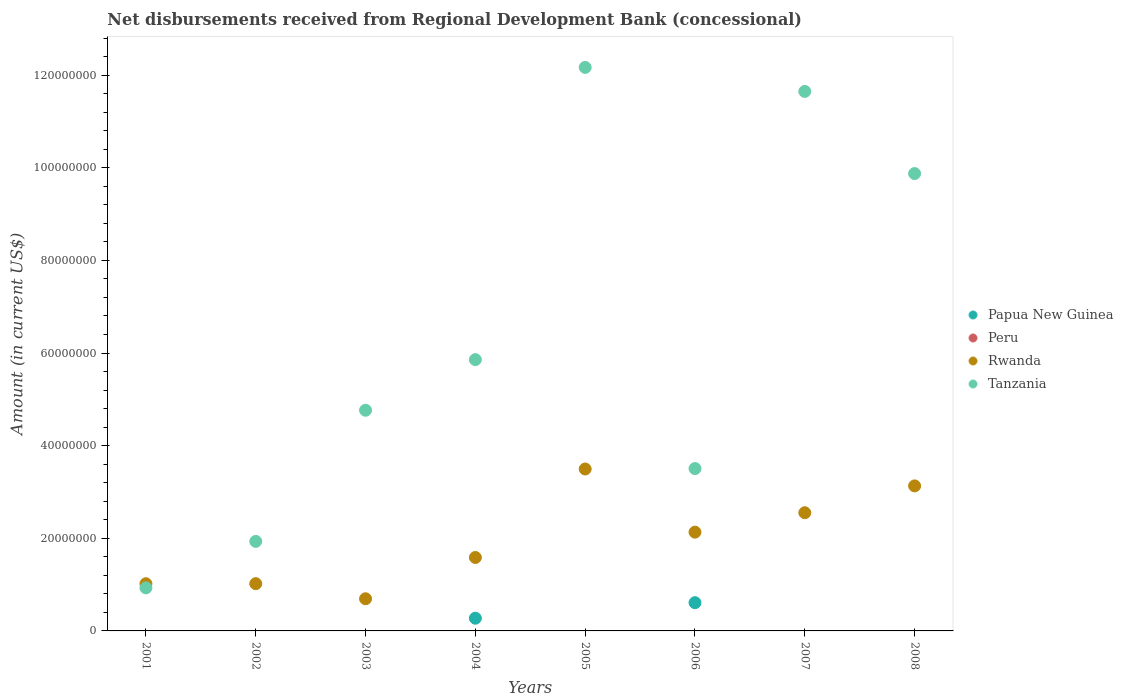How many different coloured dotlines are there?
Give a very brief answer. 3. Is the number of dotlines equal to the number of legend labels?
Keep it short and to the point. No. What is the amount of disbursements received from Regional Development Bank in Rwanda in 2008?
Ensure brevity in your answer.  3.13e+07. Across all years, what is the maximum amount of disbursements received from Regional Development Bank in Rwanda?
Offer a terse response. 3.50e+07. Across all years, what is the minimum amount of disbursements received from Regional Development Bank in Tanzania?
Give a very brief answer. 9.30e+06. What is the total amount of disbursements received from Regional Development Bank in Peru in the graph?
Your answer should be very brief. 0. What is the difference between the amount of disbursements received from Regional Development Bank in Rwanda in 2004 and that in 2007?
Your answer should be compact. -9.66e+06. What is the difference between the amount of disbursements received from Regional Development Bank in Papua New Guinea in 2006 and the amount of disbursements received from Regional Development Bank in Rwanda in 2008?
Provide a succinct answer. -2.52e+07. What is the average amount of disbursements received from Regional Development Bank in Rwanda per year?
Provide a short and direct response. 1.95e+07. In the year 2007, what is the difference between the amount of disbursements received from Regional Development Bank in Tanzania and amount of disbursements received from Regional Development Bank in Rwanda?
Provide a succinct answer. 9.10e+07. What is the ratio of the amount of disbursements received from Regional Development Bank in Rwanda in 2002 to that in 2004?
Offer a terse response. 0.64. Is the amount of disbursements received from Regional Development Bank in Tanzania in 2006 less than that in 2008?
Make the answer very short. Yes. What is the difference between the highest and the second highest amount of disbursements received from Regional Development Bank in Rwanda?
Your response must be concise. 3.65e+06. What is the difference between the highest and the lowest amount of disbursements received from Regional Development Bank in Papua New Guinea?
Offer a very short reply. 6.10e+06. Is the sum of the amount of disbursements received from Regional Development Bank in Rwanda in 2001 and 2002 greater than the maximum amount of disbursements received from Regional Development Bank in Peru across all years?
Make the answer very short. Yes. Is it the case that in every year, the sum of the amount of disbursements received from Regional Development Bank in Rwanda and amount of disbursements received from Regional Development Bank in Papua New Guinea  is greater than the amount of disbursements received from Regional Development Bank in Tanzania?
Give a very brief answer. No. Is the amount of disbursements received from Regional Development Bank in Papua New Guinea strictly less than the amount of disbursements received from Regional Development Bank in Rwanda over the years?
Provide a succinct answer. Yes. How many dotlines are there?
Keep it short and to the point. 3. Are the values on the major ticks of Y-axis written in scientific E-notation?
Your answer should be very brief. No. Does the graph contain any zero values?
Ensure brevity in your answer.  Yes. Does the graph contain grids?
Provide a short and direct response. No. How are the legend labels stacked?
Make the answer very short. Vertical. What is the title of the graph?
Your response must be concise. Net disbursements received from Regional Development Bank (concessional). Does "Sweden" appear as one of the legend labels in the graph?
Provide a succinct answer. No. What is the label or title of the Y-axis?
Offer a very short reply. Amount (in current US$). What is the Amount (in current US$) in Papua New Guinea in 2001?
Provide a short and direct response. 0. What is the Amount (in current US$) in Rwanda in 2001?
Give a very brief answer. 1.02e+07. What is the Amount (in current US$) of Tanzania in 2001?
Provide a succinct answer. 9.30e+06. What is the Amount (in current US$) in Papua New Guinea in 2002?
Give a very brief answer. 0. What is the Amount (in current US$) in Rwanda in 2002?
Offer a very short reply. 1.02e+07. What is the Amount (in current US$) in Tanzania in 2002?
Your answer should be very brief. 1.93e+07. What is the Amount (in current US$) in Peru in 2003?
Keep it short and to the point. 0. What is the Amount (in current US$) of Rwanda in 2003?
Provide a succinct answer. 6.94e+06. What is the Amount (in current US$) in Tanzania in 2003?
Make the answer very short. 4.76e+07. What is the Amount (in current US$) in Papua New Guinea in 2004?
Your answer should be compact. 2.74e+06. What is the Amount (in current US$) of Rwanda in 2004?
Provide a short and direct response. 1.59e+07. What is the Amount (in current US$) of Tanzania in 2004?
Your answer should be very brief. 5.86e+07. What is the Amount (in current US$) of Papua New Guinea in 2005?
Make the answer very short. 0. What is the Amount (in current US$) in Rwanda in 2005?
Keep it short and to the point. 3.50e+07. What is the Amount (in current US$) of Tanzania in 2005?
Ensure brevity in your answer.  1.22e+08. What is the Amount (in current US$) in Papua New Guinea in 2006?
Keep it short and to the point. 6.10e+06. What is the Amount (in current US$) of Peru in 2006?
Offer a terse response. 0. What is the Amount (in current US$) in Rwanda in 2006?
Give a very brief answer. 2.13e+07. What is the Amount (in current US$) of Tanzania in 2006?
Make the answer very short. 3.51e+07. What is the Amount (in current US$) in Papua New Guinea in 2007?
Give a very brief answer. 0. What is the Amount (in current US$) of Peru in 2007?
Your answer should be very brief. 0. What is the Amount (in current US$) of Rwanda in 2007?
Your answer should be very brief. 2.55e+07. What is the Amount (in current US$) in Tanzania in 2007?
Provide a succinct answer. 1.16e+08. What is the Amount (in current US$) in Papua New Guinea in 2008?
Make the answer very short. 0. What is the Amount (in current US$) in Peru in 2008?
Your answer should be very brief. 0. What is the Amount (in current US$) in Rwanda in 2008?
Provide a succinct answer. 3.13e+07. What is the Amount (in current US$) in Tanzania in 2008?
Make the answer very short. 9.87e+07. Across all years, what is the maximum Amount (in current US$) in Papua New Guinea?
Make the answer very short. 6.10e+06. Across all years, what is the maximum Amount (in current US$) in Rwanda?
Keep it short and to the point. 3.50e+07. Across all years, what is the maximum Amount (in current US$) of Tanzania?
Your answer should be compact. 1.22e+08. Across all years, what is the minimum Amount (in current US$) in Rwanda?
Make the answer very short. 6.94e+06. Across all years, what is the minimum Amount (in current US$) in Tanzania?
Ensure brevity in your answer.  9.30e+06. What is the total Amount (in current US$) in Papua New Guinea in the graph?
Ensure brevity in your answer.  8.84e+06. What is the total Amount (in current US$) in Rwanda in the graph?
Provide a succinct answer. 1.56e+08. What is the total Amount (in current US$) in Tanzania in the graph?
Your answer should be very brief. 5.07e+08. What is the difference between the Amount (in current US$) of Rwanda in 2001 and that in 2002?
Offer a terse response. -1.30e+04. What is the difference between the Amount (in current US$) in Tanzania in 2001 and that in 2002?
Offer a terse response. -1.00e+07. What is the difference between the Amount (in current US$) in Rwanda in 2001 and that in 2003?
Ensure brevity in your answer.  3.25e+06. What is the difference between the Amount (in current US$) of Tanzania in 2001 and that in 2003?
Keep it short and to the point. -3.83e+07. What is the difference between the Amount (in current US$) of Rwanda in 2001 and that in 2004?
Keep it short and to the point. -5.66e+06. What is the difference between the Amount (in current US$) of Tanzania in 2001 and that in 2004?
Offer a terse response. -4.93e+07. What is the difference between the Amount (in current US$) in Rwanda in 2001 and that in 2005?
Your response must be concise. -2.48e+07. What is the difference between the Amount (in current US$) in Tanzania in 2001 and that in 2005?
Offer a terse response. -1.12e+08. What is the difference between the Amount (in current US$) of Rwanda in 2001 and that in 2006?
Offer a terse response. -1.11e+07. What is the difference between the Amount (in current US$) in Tanzania in 2001 and that in 2006?
Offer a very short reply. -2.58e+07. What is the difference between the Amount (in current US$) of Rwanda in 2001 and that in 2007?
Your answer should be very brief. -1.53e+07. What is the difference between the Amount (in current US$) of Tanzania in 2001 and that in 2007?
Give a very brief answer. -1.07e+08. What is the difference between the Amount (in current US$) in Rwanda in 2001 and that in 2008?
Make the answer very short. -2.11e+07. What is the difference between the Amount (in current US$) in Tanzania in 2001 and that in 2008?
Your answer should be compact. -8.94e+07. What is the difference between the Amount (in current US$) in Rwanda in 2002 and that in 2003?
Give a very brief answer. 3.26e+06. What is the difference between the Amount (in current US$) in Tanzania in 2002 and that in 2003?
Your answer should be compact. -2.83e+07. What is the difference between the Amount (in current US$) of Rwanda in 2002 and that in 2004?
Your answer should be very brief. -5.65e+06. What is the difference between the Amount (in current US$) of Tanzania in 2002 and that in 2004?
Give a very brief answer. -3.92e+07. What is the difference between the Amount (in current US$) of Rwanda in 2002 and that in 2005?
Keep it short and to the point. -2.48e+07. What is the difference between the Amount (in current US$) of Tanzania in 2002 and that in 2005?
Your response must be concise. -1.02e+08. What is the difference between the Amount (in current US$) of Rwanda in 2002 and that in 2006?
Ensure brevity in your answer.  -1.11e+07. What is the difference between the Amount (in current US$) in Tanzania in 2002 and that in 2006?
Provide a succinct answer. -1.57e+07. What is the difference between the Amount (in current US$) of Rwanda in 2002 and that in 2007?
Your response must be concise. -1.53e+07. What is the difference between the Amount (in current US$) of Tanzania in 2002 and that in 2007?
Provide a short and direct response. -9.71e+07. What is the difference between the Amount (in current US$) of Rwanda in 2002 and that in 2008?
Your response must be concise. -2.11e+07. What is the difference between the Amount (in current US$) of Tanzania in 2002 and that in 2008?
Ensure brevity in your answer.  -7.94e+07. What is the difference between the Amount (in current US$) in Rwanda in 2003 and that in 2004?
Offer a very short reply. -8.91e+06. What is the difference between the Amount (in current US$) in Tanzania in 2003 and that in 2004?
Offer a terse response. -1.09e+07. What is the difference between the Amount (in current US$) in Rwanda in 2003 and that in 2005?
Your response must be concise. -2.80e+07. What is the difference between the Amount (in current US$) of Tanzania in 2003 and that in 2005?
Your answer should be compact. -7.40e+07. What is the difference between the Amount (in current US$) of Rwanda in 2003 and that in 2006?
Give a very brief answer. -1.44e+07. What is the difference between the Amount (in current US$) of Tanzania in 2003 and that in 2006?
Ensure brevity in your answer.  1.26e+07. What is the difference between the Amount (in current US$) of Rwanda in 2003 and that in 2007?
Offer a terse response. -1.86e+07. What is the difference between the Amount (in current US$) in Tanzania in 2003 and that in 2007?
Your answer should be very brief. -6.88e+07. What is the difference between the Amount (in current US$) in Rwanda in 2003 and that in 2008?
Make the answer very short. -2.44e+07. What is the difference between the Amount (in current US$) in Tanzania in 2003 and that in 2008?
Your response must be concise. -5.11e+07. What is the difference between the Amount (in current US$) in Rwanda in 2004 and that in 2005?
Make the answer very short. -1.91e+07. What is the difference between the Amount (in current US$) in Tanzania in 2004 and that in 2005?
Make the answer very short. -6.31e+07. What is the difference between the Amount (in current US$) in Papua New Guinea in 2004 and that in 2006?
Offer a very short reply. -3.35e+06. What is the difference between the Amount (in current US$) in Rwanda in 2004 and that in 2006?
Offer a very short reply. -5.47e+06. What is the difference between the Amount (in current US$) of Tanzania in 2004 and that in 2006?
Ensure brevity in your answer.  2.35e+07. What is the difference between the Amount (in current US$) of Rwanda in 2004 and that in 2007?
Keep it short and to the point. -9.66e+06. What is the difference between the Amount (in current US$) in Tanzania in 2004 and that in 2007?
Your answer should be compact. -5.79e+07. What is the difference between the Amount (in current US$) in Rwanda in 2004 and that in 2008?
Ensure brevity in your answer.  -1.55e+07. What is the difference between the Amount (in current US$) of Tanzania in 2004 and that in 2008?
Provide a short and direct response. -4.02e+07. What is the difference between the Amount (in current US$) of Rwanda in 2005 and that in 2006?
Offer a very short reply. 1.36e+07. What is the difference between the Amount (in current US$) in Tanzania in 2005 and that in 2006?
Make the answer very short. 8.66e+07. What is the difference between the Amount (in current US$) of Rwanda in 2005 and that in 2007?
Offer a terse response. 9.44e+06. What is the difference between the Amount (in current US$) of Tanzania in 2005 and that in 2007?
Provide a succinct answer. 5.19e+06. What is the difference between the Amount (in current US$) of Rwanda in 2005 and that in 2008?
Provide a short and direct response. 3.65e+06. What is the difference between the Amount (in current US$) in Tanzania in 2005 and that in 2008?
Offer a very short reply. 2.29e+07. What is the difference between the Amount (in current US$) in Rwanda in 2006 and that in 2007?
Offer a terse response. -4.20e+06. What is the difference between the Amount (in current US$) of Tanzania in 2006 and that in 2007?
Provide a short and direct response. -8.14e+07. What is the difference between the Amount (in current US$) in Rwanda in 2006 and that in 2008?
Make the answer very short. -9.99e+06. What is the difference between the Amount (in current US$) of Tanzania in 2006 and that in 2008?
Keep it short and to the point. -6.37e+07. What is the difference between the Amount (in current US$) in Rwanda in 2007 and that in 2008?
Provide a short and direct response. -5.79e+06. What is the difference between the Amount (in current US$) in Tanzania in 2007 and that in 2008?
Provide a succinct answer. 1.77e+07. What is the difference between the Amount (in current US$) in Rwanda in 2001 and the Amount (in current US$) in Tanzania in 2002?
Provide a short and direct response. -9.14e+06. What is the difference between the Amount (in current US$) in Rwanda in 2001 and the Amount (in current US$) in Tanzania in 2003?
Offer a terse response. -3.75e+07. What is the difference between the Amount (in current US$) in Rwanda in 2001 and the Amount (in current US$) in Tanzania in 2004?
Your response must be concise. -4.84e+07. What is the difference between the Amount (in current US$) in Rwanda in 2001 and the Amount (in current US$) in Tanzania in 2005?
Ensure brevity in your answer.  -1.11e+08. What is the difference between the Amount (in current US$) in Rwanda in 2001 and the Amount (in current US$) in Tanzania in 2006?
Keep it short and to the point. -2.49e+07. What is the difference between the Amount (in current US$) in Rwanda in 2001 and the Amount (in current US$) in Tanzania in 2007?
Offer a very short reply. -1.06e+08. What is the difference between the Amount (in current US$) of Rwanda in 2001 and the Amount (in current US$) of Tanzania in 2008?
Offer a very short reply. -8.86e+07. What is the difference between the Amount (in current US$) in Rwanda in 2002 and the Amount (in current US$) in Tanzania in 2003?
Offer a very short reply. -3.74e+07. What is the difference between the Amount (in current US$) of Rwanda in 2002 and the Amount (in current US$) of Tanzania in 2004?
Ensure brevity in your answer.  -4.84e+07. What is the difference between the Amount (in current US$) in Rwanda in 2002 and the Amount (in current US$) in Tanzania in 2005?
Your answer should be very brief. -1.11e+08. What is the difference between the Amount (in current US$) in Rwanda in 2002 and the Amount (in current US$) in Tanzania in 2006?
Ensure brevity in your answer.  -2.49e+07. What is the difference between the Amount (in current US$) in Rwanda in 2002 and the Amount (in current US$) in Tanzania in 2007?
Give a very brief answer. -1.06e+08. What is the difference between the Amount (in current US$) in Rwanda in 2002 and the Amount (in current US$) in Tanzania in 2008?
Your answer should be very brief. -8.85e+07. What is the difference between the Amount (in current US$) in Rwanda in 2003 and the Amount (in current US$) in Tanzania in 2004?
Make the answer very short. -5.16e+07. What is the difference between the Amount (in current US$) in Rwanda in 2003 and the Amount (in current US$) in Tanzania in 2005?
Give a very brief answer. -1.15e+08. What is the difference between the Amount (in current US$) of Rwanda in 2003 and the Amount (in current US$) of Tanzania in 2006?
Keep it short and to the point. -2.81e+07. What is the difference between the Amount (in current US$) in Rwanda in 2003 and the Amount (in current US$) in Tanzania in 2007?
Provide a succinct answer. -1.10e+08. What is the difference between the Amount (in current US$) of Rwanda in 2003 and the Amount (in current US$) of Tanzania in 2008?
Offer a terse response. -9.18e+07. What is the difference between the Amount (in current US$) of Papua New Guinea in 2004 and the Amount (in current US$) of Rwanda in 2005?
Offer a terse response. -3.22e+07. What is the difference between the Amount (in current US$) in Papua New Guinea in 2004 and the Amount (in current US$) in Tanzania in 2005?
Your response must be concise. -1.19e+08. What is the difference between the Amount (in current US$) of Rwanda in 2004 and the Amount (in current US$) of Tanzania in 2005?
Your answer should be compact. -1.06e+08. What is the difference between the Amount (in current US$) of Papua New Guinea in 2004 and the Amount (in current US$) of Rwanda in 2006?
Provide a succinct answer. -1.86e+07. What is the difference between the Amount (in current US$) of Papua New Guinea in 2004 and the Amount (in current US$) of Tanzania in 2006?
Provide a short and direct response. -3.23e+07. What is the difference between the Amount (in current US$) of Rwanda in 2004 and the Amount (in current US$) of Tanzania in 2006?
Your answer should be very brief. -1.92e+07. What is the difference between the Amount (in current US$) in Papua New Guinea in 2004 and the Amount (in current US$) in Rwanda in 2007?
Your response must be concise. -2.28e+07. What is the difference between the Amount (in current US$) in Papua New Guinea in 2004 and the Amount (in current US$) in Tanzania in 2007?
Ensure brevity in your answer.  -1.14e+08. What is the difference between the Amount (in current US$) of Rwanda in 2004 and the Amount (in current US$) of Tanzania in 2007?
Your answer should be very brief. -1.01e+08. What is the difference between the Amount (in current US$) in Papua New Guinea in 2004 and the Amount (in current US$) in Rwanda in 2008?
Offer a very short reply. -2.86e+07. What is the difference between the Amount (in current US$) of Papua New Guinea in 2004 and the Amount (in current US$) of Tanzania in 2008?
Your answer should be compact. -9.60e+07. What is the difference between the Amount (in current US$) in Rwanda in 2004 and the Amount (in current US$) in Tanzania in 2008?
Provide a succinct answer. -8.29e+07. What is the difference between the Amount (in current US$) of Rwanda in 2005 and the Amount (in current US$) of Tanzania in 2006?
Provide a succinct answer. -9.60e+04. What is the difference between the Amount (in current US$) in Rwanda in 2005 and the Amount (in current US$) in Tanzania in 2007?
Offer a terse response. -8.15e+07. What is the difference between the Amount (in current US$) in Rwanda in 2005 and the Amount (in current US$) in Tanzania in 2008?
Offer a very short reply. -6.38e+07. What is the difference between the Amount (in current US$) in Papua New Guinea in 2006 and the Amount (in current US$) in Rwanda in 2007?
Ensure brevity in your answer.  -1.94e+07. What is the difference between the Amount (in current US$) in Papua New Guinea in 2006 and the Amount (in current US$) in Tanzania in 2007?
Ensure brevity in your answer.  -1.10e+08. What is the difference between the Amount (in current US$) in Rwanda in 2006 and the Amount (in current US$) in Tanzania in 2007?
Ensure brevity in your answer.  -9.52e+07. What is the difference between the Amount (in current US$) of Papua New Guinea in 2006 and the Amount (in current US$) of Rwanda in 2008?
Your answer should be very brief. -2.52e+07. What is the difference between the Amount (in current US$) in Papua New Guinea in 2006 and the Amount (in current US$) in Tanzania in 2008?
Offer a very short reply. -9.26e+07. What is the difference between the Amount (in current US$) in Rwanda in 2006 and the Amount (in current US$) in Tanzania in 2008?
Offer a very short reply. -7.74e+07. What is the difference between the Amount (in current US$) of Rwanda in 2007 and the Amount (in current US$) of Tanzania in 2008?
Offer a very short reply. -7.32e+07. What is the average Amount (in current US$) in Papua New Guinea per year?
Provide a succinct answer. 1.11e+06. What is the average Amount (in current US$) in Rwanda per year?
Offer a terse response. 1.95e+07. What is the average Amount (in current US$) in Tanzania per year?
Your response must be concise. 6.33e+07. In the year 2001, what is the difference between the Amount (in current US$) in Rwanda and Amount (in current US$) in Tanzania?
Provide a short and direct response. 8.95e+05. In the year 2002, what is the difference between the Amount (in current US$) of Rwanda and Amount (in current US$) of Tanzania?
Your answer should be very brief. -9.13e+06. In the year 2003, what is the difference between the Amount (in current US$) in Rwanda and Amount (in current US$) in Tanzania?
Your answer should be compact. -4.07e+07. In the year 2004, what is the difference between the Amount (in current US$) in Papua New Guinea and Amount (in current US$) in Rwanda?
Provide a short and direct response. -1.31e+07. In the year 2004, what is the difference between the Amount (in current US$) of Papua New Guinea and Amount (in current US$) of Tanzania?
Provide a short and direct response. -5.58e+07. In the year 2004, what is the difference between the Amount (in current US$) of Rwanda and Amount (in current US$) of Tanzania?
Make the answer very short. -4.27e+07. In the year 2005, what is the difference between the Amount (in current US$) in Rwanda and Amount (in current US$) in Tanzania?
Your response must be concise. -8.67e+07. In the year 2006, what is the difference between the Amount (in current US$) in Papua New Guinea and Amount (in current US$) in Rwanda?
Offer a terse response. -1.52e+07. In the year 2006, what is the difference between the Amount (in current US$) of Papua New Guinea and Amount (in current US$) of Tanzania?
Ensure brevity in your answer.  -2.90e+07. In the year 2006, what is the difference between the Amount (in current US$) of Rwanda and Amount (in current US$) of Tanzania?
Ensure brevity in your answer.  -1.37e+07. In the year 2007, what is the difference between the Amount (in current US$) of Rwanda and Amount (in current US$) of Tanzania?
Keep it short and to the point. -9.10e+07. In the year 2008, what is the difference between the Amount (in current US$) of Rwanda and Amount (in current US$) of Tanzania?
Offer a terse response. -6.74e+07. What is the ratio of the Amount (in current US$) of Tanzania in 2001 to that in 2002?
Offer a very short reply. 0.48. What is the ratio of the Amount (in current US$) in Rwanda in 2001 to that in 2003?
Give a very brief answer. 1.47. What is the ratio of the Amount (in current US$) of Tanzania in 2001 to that in 2003?
Ensure brevity in your answer.  0.2. What is the ratio of the Amount (in current US$) of Rwanda in 2001 to that in 2004?
Offer a terse response. 0.64. What is the ratio of the Amount (in current US$) of Tanzania in 2001 to that in 2004?
Make the answer very short. 0.16. What is the ratio of the Amount (in current US$) of Rwanda in 2001 to that in 2005?
Your answer should be very brief. 0.29. What is the ratio of the Amount (in current US$) in Tanzania in 2001 to that in 2005?
Keep it short and to the point. 0.08. What is the ratio of the Amount (in current US$) of Rwanda in 2001 to that in 2006?
Your response must be concise. 0.48. What is the ratio of the Amount (in current US$) of Tanzania in 2001 to that in 2006?
Provide a short and direct response. 0.27. What is the ratio of the Amount (in current US$) of Rwanda in 2001 to that in 2007?
Ensure brevity in your answer.  0.4. What is the ratio of the Amount (in current US$) in Tanzania in 2001 to that in 2007?
Keep it short and to the point. 0.08. What is the ratio of the Amount (in current US$) of Rwanda in 2001 to that in 2008?
Provide a short and direct response. 0.33. What is the ratio of the Amount (in current US$) of Tanzania in 2001 to that in 2008?
Offer a terse response. 0.09. What is the ratio of the Amount (in current US$) in Rwanda in 2002 to that in 2003?
Ensure brevity in your answer.  1.47. What is the ratio of the Amount (in current US$) of Tanzania in 2002 to that in 2003?
Your response must be concise. 0.41. What is the ratio of the Amount (in current US$) of Rwanda in 2002 to that in 2004?
Provide a succinct answer. 0.64. What is the ratio of the Amount (in current US$) in Tanzania in 2002 to that in 2004?
Make the answer very short. 0.33. What is the ratio of the Amount (in current US$) of Rwanda in 2002 to that in 2005?
Provide a short and direct response. 0.29. What is the ratio of the Amount (in current US$) in Tanzania in 2002 to that in 2005?
Your answer should be compact. 0.16. What is the ratio of the Amount (in current US$) in Rwanda in 2002 to that in 2006?
Ensure brevity in your answer.  0.48. What is the ratio of the Amount (in current US$) in Tanzania in 2002 to that in 2006?
Keep it short and to the point. 0.55. What is the ratio of the Amount (in current US$) of Rwanda in 2002 to that in 2007?
Your response must be concise. 0.4. What is the ratio of the Amount (in current US$) in Tanzania in 2002 to that in 2007?
Ensure brevity in your answer.  0.17. What is the ratio of the Amount (in current US$) in Rwanda in 2002 to that in 2008?
Make the answer very short. 0.33. What is the ratio of the Amount (in current US$) of Tanzania in 2002 to that in 2008?
Your answer should be compact. 0.2. What is the ratio of the Amount (in current US$) in Rwanda in 2003 to that in 2004?
Your response must be concise. 0.44. What is the ratio of the Amount (in current US$) of Tanzania in 2003 to that in 2004?
Keep it short and to the point. 0.81. What is the ratio of the Amount (in current US$) in Rwanda in 2003 to that in 2005?
Ensure brevity in your answer.  0.2. What is the ratio of the Amount (in current US$) in Tanzania in 2003 to that in 2005?
Provide a short and direct response. 0.39. What is the ratio of the Amount (in current US$) of Rwanda in 2003 to that in 2006?
Give a very brief answer. 0.33. What is the ratio of the Amount (in current US$) in Tanzania in 2003 to that in 2006?
Your answer should be very brief. 1.36. What is the ratio of the Amount (in current US$) of Rwanda in 2003 to that in 2007?
Offer a very short reply. 0.27. What is the ratio of the Amount (in current US$) in Tanzania in 2003 to that in 2007?
Give a very brief answer. 0.41. What is the ratio of the Amount (in current US$) of Rwanda in 2003 to that in 2008?
Your answer should be compact. 0.22. What is the ratio of the Amount (in current US$) in Tanzania in 2003 to that in 2008?
Offer a very short reply. 0.48. What is the ratio of the Amount (in current US$) in Rwanda in 2004 to that in 2005?
Ensure brevity in your answer.  0.45. What is the ratio of the Amount (in current US$) of Tanzania in 2004 to that in 2005?
Provide a succinct answer. 0.48. What is the ratio of the Amount (in current US$) of Papua New Guinea in 2004 to that in 2006?
Offer a terse response. 0.45. What is the ratio of the Amount (in current US$) in Rwanda in 2004 to that in 2006?
Offer a very short reply. 0.74. What is the ratio of the Amount (in current US$) in Tanzania in 2004 to that in 2006?
Make the answer very short. 1.67. What is the ratio of the Amount (in current US$) of Rwanda in 2004 to that in 2007?
Offer a terse response. 0.62. What is the ratio of the Amount (in current US$) in Tanzania in 2004 to that in 2007?
Give a very brief answer. 0.5. What is the ratio of the Amount (in current US$) of Rwanda in 2004 to that in 2008?
Your answer should be compact. 0.51. What is the ratio of the Amount (in current US$) in Tanzania in 2004 to that in 2008?
Make the answer very short. 0.59. What is the ratio of the Amount (in current US$) of Rwanda in 2005 to that in 2006?
Provide a succinct answer. 1.64. What is the ratio of the Amount (in current US$) of Tanzania in 2005 to that in 2006?
Keep it short and to the point. 3.47. What is the ratio of the Amount (in current US$) of Rwanda in 2005 to that in 2007?
Ensure brevity in your answer.  1.37. What is the ratio of the Amount (in current US$) of Tanzania in 2005 to that in 2007?
Make the answer very short. 1.04. What is the ratio of the Amount (in current US$) in Rwanda in 2005 to that in 2008?
Your answer should be very brief. 1.12. What is the ratio of the Amount (in current US$) of Tanzania in 2005 to that in 2008?
Offer a terse response. 1.23. What is the ratio of the Amount (in current US$) of Rwanda in 2006 to that in 2007?
Give a very brief answer. 0.84. What is the ratio of the Amount (in current US$) of Tanzania in 2006 to that in 2007?
Give a very brief answer. 0.3. What is the ratio of the Amount (in current US$) of Rwanda in 2006 to that in 2008?
Provide a short and direct response. 0.68. What is the ratio of the Amount (in current US$) of Tanzania in 2006 to that in 2008?
Ensure brevity in your answer.  0.35. What is the ratio of the Amount (in current US$) of Rwanda in 2007 to that in 2008?
Ensure brevity in your answer.  0.81. What is the ratio of the Amount (in current US$) in Tanzania in 2007 to that in 2008?
Ensure brevity in your answer.  1.18. What is the difference between the highest and the second highest Amount (in current US$) of Rwanda?
Your response must be concise. 3.65e+06. What is the difference between the highest and the second highest Amount (in current US$) of Tanzania?
Provide a short and direct response. 5.19e+06. What is the difference between the highest and the lowest Amount (in current US$) in Papua New Guinea?
Offer a terse response. 6.10e+06. What is the difference between the highest and the lowest Amount (in current US$) of Rwanda?
Provide a short and direct response. 2.80e+07. What is the difference between the highest and the lowest Amount (in current US$) of Tanzania?
Keep it short and to the point. 1.12e+08. 